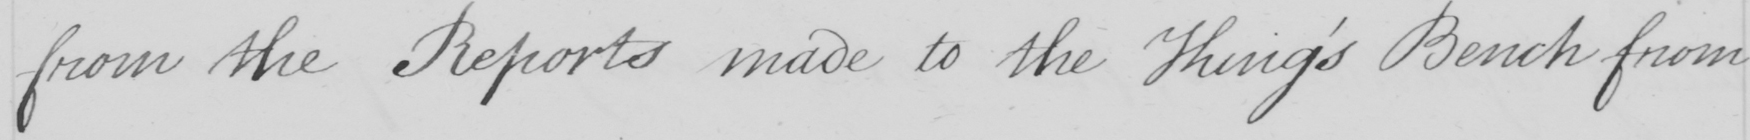What does this handwritten line say? from the Reports made to the King ' s Bench from 